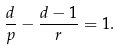Convert formula to latex. <formula><loc_0><loc_0><loc_500><loc_500>\frac { d } { p } - \frac { d - 1 } { r } = 1 .</formula> 